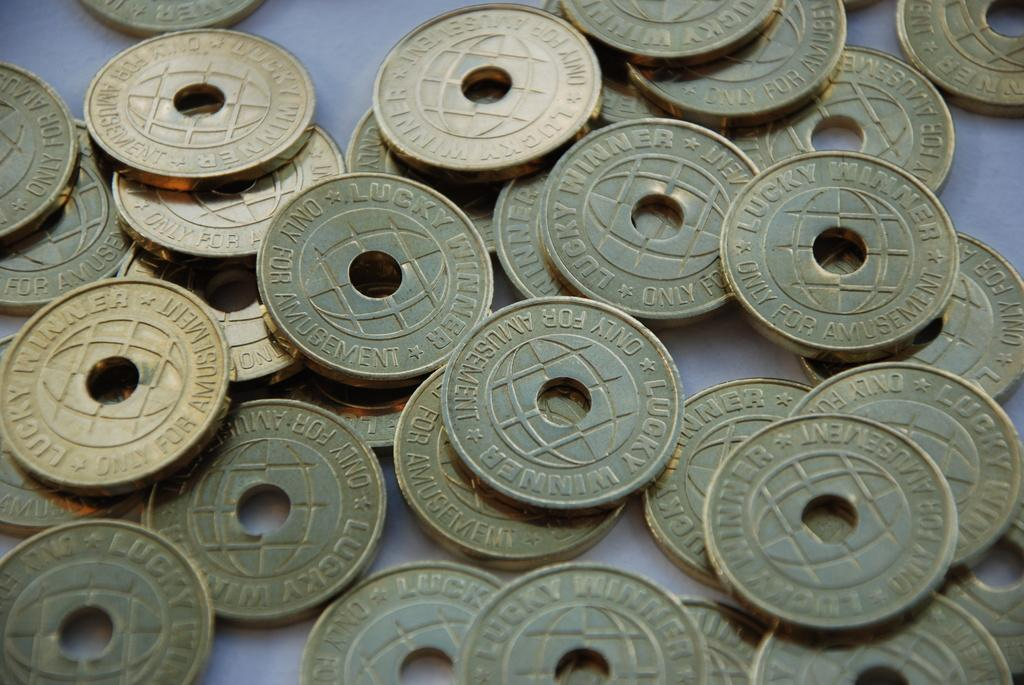<image>
Provide a brief description of the given image. A pile of coins that all say Lucky Winner on them. 